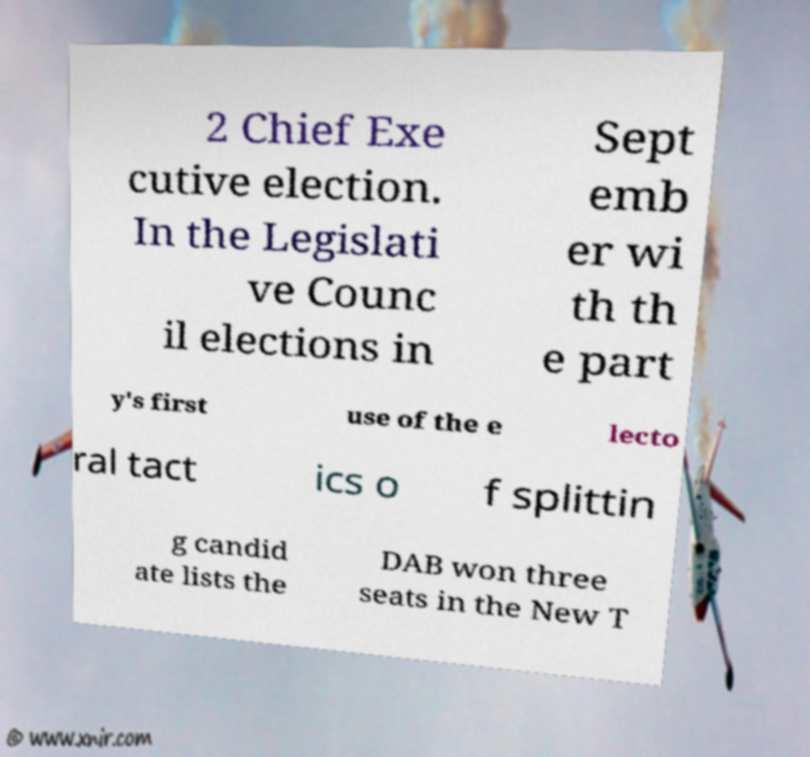Could you assist in decoding the text presented in this image and type it out clearly? 2 Chief Exe cutive election. In the Legislati ve Counc il elections in Sept emb er wi th th e part y's first use of the e lecto ral tact ics o f splittin g candid ate lists the DAB won three seats in the New T 